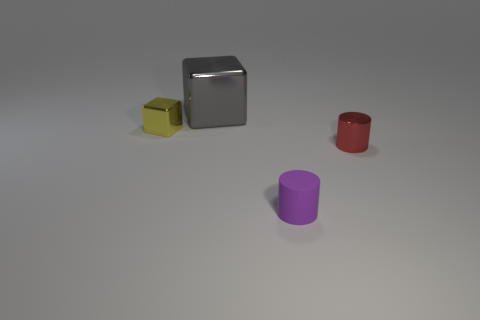Is there anything else that has the same material as the purple object?
Ensure brevity in your answer.  No. What is the size of the gray metallic cube?
Your answer should be very brief. Large. Are there more red metal things that are on the right side of the rubber object than tiny purple matte cylinders that are on the left side of the tiny yellow metal thing?
Provide a succinct answer. Yes. How many tiny things are in front of the tiny object right of the small purple rubber thing?
Your answer should be compact. 1. There is a small thing behind the red shiny object; is it the same shape as the gray shiny thing?
Offer a terse response. Yes. What is the material of the other small object that is the same shape as the red object?
Provide a succinct answer. Rubber. What number of yellow blocks are the same size as the gray cube?
Your answer should be very brief. 0. There is a small thing that is to the right of the small block and to the left of the red metal cylinder; what color is it?
Offer a terse response. Purple. Is the number of small cylinders less than the number of matte things?
Your answer should be compact. No. Does the rubber cylinder have the same color as the cylinder on the right side of the purple cylinder?
Your response must be concise. No. 